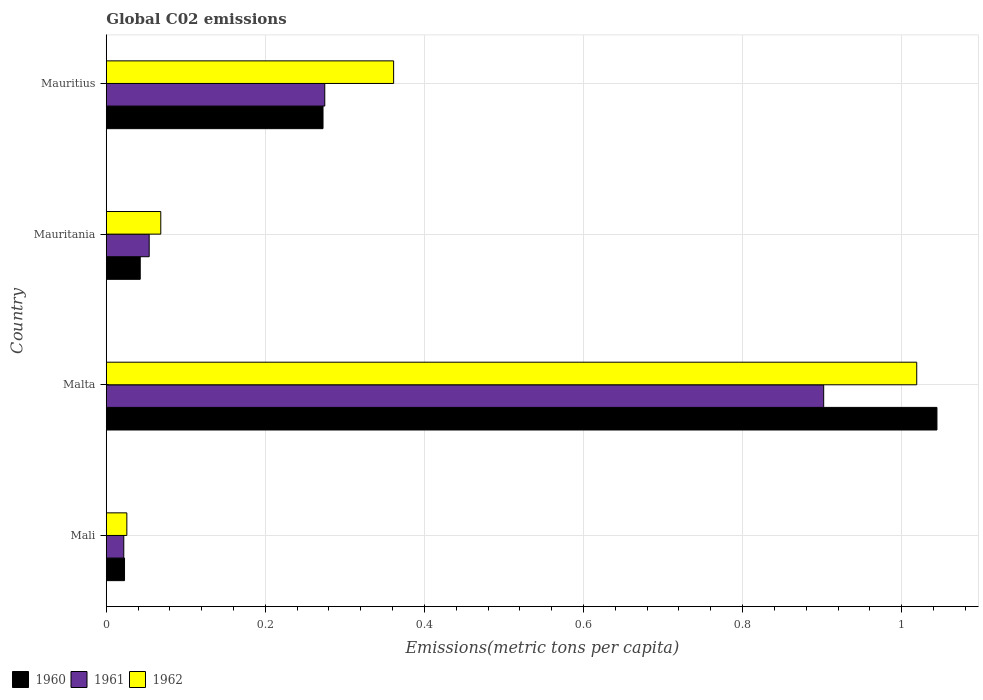How many groups of bars are there?
Offer a very short reply. 4. Are the number of bars per tick equal to the number of legend labels?
Keep it short and to the point. Yes. How many bars are there on the 2nd tick from the bottom?
Provide a succinct answer. 3. What is the label of the 4th group of bars from the top?
Ensure brevity in your answer.  Mali. In how many cases, is the number of bars for a given country not equal to the number of legend labels?
Your answer should be very brief. 0. What is the amount of CO2 emitted in in 1960 in Mauritania?
Provide a short and direct response. 0.04. Across all countries, what is the maximum amount of CO2 emitted in in 1962?
Ensure brevity in your answer.  1.02. Across all countries, what is the minimum amount of CO2 emitted in in 1961?
Give a very brief answer. 0.02. In which country was the amount of CO2 emitted in in 1961 maximum?
Your answer should be very brief. Malta. In which country was the amount of CO2 emitted in in 1962 minimum?
Make the answer very short. Mali. What is the total amount of CO2 emitted in in 1962 in the graph?
Provide a short and direct response. 1.47. What is the difference between the amount of CO2 emitted in in 1962 in Mali and that in Mauritania?
Offer a terse response. -0.04. What is the difference between the amount of CO2 emitted in in 1961 in Mauritius and the amount of CO2 emitted in in 1962 in Mauritania?
Give a very brief answer. 0.21. What is the average amount of CO2 emitted in in 1961 per country?
Your answer should be compact. 0.31. What is the difference between the amount of CO2 emitted in in 1962 and amount of CO2 emitted in in 1960 in Mali?
Offer a very short reply. 0. In how many countries, is the amount of CO2 emitted in in 1962 greater than 0.56 metric tons per capita?
Make the answer very short. 1. What is the ratio of the amount of CO2 emitted in in 1960 in Mauritania to that in Mauritius?
Ensure brevity in your answer.  0.16. Is the difference between the amount of CO2 emitted in in 1962 in Malta and Mauritania greater than the difference between the amount of CO2 emitted in in 1960 in Malta and Mauritania?
Make the answer very short. No. What is the difference between the highest and the second highest amount of CO2 emitted in in 1960?
Keep it short and to the point. 0.77. What is the difference between the highest and the lowest amount of CO2 emitted in in 1960?
Provide a succinct answer. 1.02. In how many countries, is the amount of CO2 emitted in in 1961 greater than the average amount of CO2 emitted in in 1961 taken over all countries?
Your response must be concise. 1. What does the 3rd bar from the bottom in Mali represents?
Your response must be concise. 1962. How many bars are there?
Offer a very short reply. 12. Are all the bars in the graph horizontal?
Provide a short and direct response. Yes. Are the values on the major ticks of X-axis written in scientific E-notation?
Offer a very short reply. No. Does the graph contain grids?
Keep it short and to the point. Yes. How many legend labels are there?
Your answer should be very brief. 3. How are the legend labels stacked?
Make the answer very short. Horizontal. What is the title of the graph?
Ensure brevity in your answer.  Global C02 emissions. What is the label or title of the X-axis?
Provide a short and direct response. Emissions(metric tons per capita). What is the Emissions(metric tons per capita) of 1960 in Mali?
Provide a short and direct response. 0.02. What is the Emissions(metric tons per capita) in 1961 in Mali?
Offer a very short reply. 0.02. What is the Emissions(metric tons per capita) in 1962 in Mali?
Make the answer very short. 0.03. What is the Emissions(metric tons per capita) of 1960 in Malta?
Give a very brief answer. 1.04. What is the Emissions(metric tons per capita) of 1961 in Malta?
Provide a short and direct response. 0.9. What is the Emissions(metric tons per capita) in 1962 in Malta?
Your answer should be very brief. 1.02. What is the Emissions(metric tons per capita) of 1960 in Mauritania?
Offer a terse response. 0.04. What is the Emissions(metric tons per capita) in 1961 in Mauritania?
Provide a succinct answer. 0.05. What is the Emissions(metric tons per capita) in 1962 in Mauritania?
Ensure brevity in your answer.  0.07. What is the Emissions(metric tons per capita) of 1960 in Mauritius?
Your answer should be compact. 0.27. What is the Emissions(metric tons per capita) in 1961 in Mauritius?
Your answer should be compact. 0.27. What is the Emissions(metric tons per capita) in 1962 in Mauritius?
Provide a succinct answer. 0.36. Across all countries, what is the maximum Emissions(metric tons per capita) in 1960?
Offer a terse response. 1.04. Across all countries, what is the maximum Emissions(metric tons per capita) in 1961?
Make the answer very short. 0.9. Across all countries, what is the maximum Emissions(metric tons per capita) in 1962?
Offer a very short reply. 1.02. Across all countries, what is the minimum Emissions(metric tons per capita) in 1960?
Your answer should be compact. 0.02. Across all countries, what is the minimum Emissions(metric tons per capita) in 1961?
Your answer should be compact. 0.02. Across all countries, what is the minimum Emissions(metric tons per capita) in 1962?
Your answer should be very brief. 0.03. What is the total Emissions(metric tons per capita) in 1960 in the graph?
Offer a terse response. 1.38. What is the total Emissions(metric tons per capita) in 1961 in the graph?
Offer a terse response. 1.25. What is the total Emissions(metric tons per capita) in 1962 in the graph?
Your answer should be compact. 1.47. What is the difference between the Emissions(metric tons per capita) of 1960 in Mali and that in Malta?
Keep it short and to the point. -1.02. What is the difference between the Emissions(metric tons per capita) of 1961 in Mali and that in Malta?
Your answer should be compact. -0.88. What is the difference between the Emissions(metric tons per capita) in 1962 in Mali and that in Malta?
Your response must be concise. -0.99. What is the difference between the Emissions(metric tons per capita) of 1960 in Mali and that in Mauritania?
Offer a terse response. -0.02. What is the difference between the Emissions(metric tons per capita) in 1961 in Mali and that in Mauritania?
Give a very brief answer. -0.03. What is the difference between the Emissions(metric tons per capita) of 1962 in Mali and that in Mauritania?
Keep it short and to the point. -0.04. What is the difference between the Emissions(metric tons per capita) of 1960 in Mali and that in Mauritius?
Your response must be concise. -0.25. What is the difference between the Emissions(metric tons per capita) of 1961 in Mali and that in Mauritius?
Your answer should be very brief. -0.25. What is the difference between the Emissions(metric tons per capita) of 1962 in Mali and that in Mauritius?
Your answer should be very brief. -0.34. What is the difference between the Emissions(metric tons per capita) of 1961 in Malta and that in Mauritania?
Your response must be concise. 0.85. What is the difference between the Emissions(metric tons per capita) of 1962 in Malta and that in Mauritania?
Offer a very short reply. 0.95. What is the difference between the Emissions(metric tons per capita) of 1960 in Malta and that in Mauritius?
Offer a terse response. 0.77. What is the difference between the Emissions(metric tons per capita) of 1961 in Malta and that in Mauritius?
Your response must be concise. 0.63. What is the difference between the Emissions(metric tons per capita) in 1962 in Malta and that in Mauritius?
Keep it short and to the point. 0.66. What is the difference between the Emissions(metric tons per capita) of 1960 in Mauritania and that in Mauritius?
Give a very brief answer. -0.23. What is the difference between the Emissions(metric tons per capita) of 1961 in Mauritania and that in Mauritius?
Provide a short and direct response. -0.22. What is the difference between the Emissions(metric tons per capita) in 1962 in Mauritania and that in Mauritius?
Give a very brief answer. -0.29. What is the difference between the Emissions(metric tons per capita) of 1960 in Mali and the Emissions(metric tons per capita) of 1961 in Malta?
Ensure brevity in your answer.  -0.88. What is the difference between the Emissions(metric tons per capita) of 1960 in Mali and the Emissions(metric tons per capita) of 1962 in Malta?
Your response must be concise. -1. What is the difference between the Emissions(metric tons per capita) in 1961 in Mali and the Emissions(metric tons per capita) in 1962 in Malta?
Offer a very short reply. -1. What is the difference between the Emissions(metric tons per capita) of 1960 in Mali and the Emissions(metric tons per capita) of 1961 in Mauritania?
Offer a terse response. -0.03. What is the difference between the Emissions(metric tons per capita) of 1960 in Mali and the Emissions(metric tons per capita) of 1962 in Mauritania?
Your answer should be very brief. -0.05. What is the difference between the Emissions(metric tons per capita) of 1961 in Mali and the Emissions(metric tons per capita) of 1962 in Mauritania?
Your response must be concise. -0.05. What is the difference between the Emissions(metric tons per capita) in 1960 in Mali and the Emissions(metric tons per capita) in 1961 in Mauritius?
Give a very brief answer. -0.25. What is the difference between the Emissions(metric tons per capita) in 1960 in Mali and the Emissions(metric tons per capita) in 1962 in Mauritius?
Give a very brief answer. -0.34. What is the difference between the Emissions(metric tons per capita) of 1961 in Mali and the Emissions(metric tons per capita) of 1962 in Mauritius?
Keep it short and to the point. -0.34. What is the difference between the Emissions(metric tons per capita) in 1960 in Malta and the Emissions(metric tons per capita) in 1961 in Mauritania?
Your response must be concise. 0.99. What is the difference between the Emissions(metric tons per capita) of 1960 in Malta and the Emissions(metric tons per capita) of 1962 in Mauritania?
Offer a terse response. 0.98. What is the difference between the Emissions(metric tons per capita) of 1961 in Malta and the Emissions(metric tons per capita) of 1962 in Mauritania?
Make the answer very short. 0.83. What is the difference between the Emissions(metric tons per capita) in 1960 in Malta and the Emissions(metric tons per capita) in 1961 in Mauritius?
Offer a very short reply. 0.77. What is the difference between the Emissions(metric tons per capita) of 1960 in Malta and the Emissions(metric tons per capita) of 1962 in Mauritius?
Your answer should be compact. 0.68. What is the difference between the Emissions(metric tons per capita) in 1961 in Malta and the Emissions(metric tons per capita) in 1962 in Mauritius?
Ensure brevity in your answer.  0.54. What is the difference between the Emissions(metric tons per capita) in 1960 in Mauritania and the Emissions(metric tons per capita) in 1961 in Mauritius?
Give a very brief answer. -0.23. What is the difference between the Emissions(metric tons per capita) in 1960 in Mauritania and the Emissions(metric tons per capita) in 1962 in Mauritius?
Ensure brevity in your answer.  -0.32. What is the difference between the Emissions(metric tons per capita) in 1961 in Mauritania and the Emissions(metric tons per capita) in 1962 in Mauritius?
Ensure brevity in your answer.  -0.31. What is the average Emissions(metric tons per capita) of 1960 per country?
Provide a succinct answer. 0.35. What is the average Emissions(metric tons per capita) in 1961 per country?
Give a very brief answer. 0.31. What is the average Emissions(metric tons per capita) of 1962 per country?
Ensure brevity in your answer.  0.37. What is the difference between the Emissions(metric tons per capita) in 1960 and Emissions(metric tons per capita) in 1961 in Mali?
Make the answer very short. 0. What is the difference between the Emissions(metric tons per capita) in 1960 and Emissions(metric tons per capita) in 1962 in Mali?
Make the answer very short. -0. What is the difference between the Emissions(metric tons per capita) of 1961 and Emissions(metric tons per capita) of 1962 in Mali?
Give a very brief answer. -0. What is the difference between the Emissions(metric tons per capita) of 1960 and Emissions(metric tons per capita) of 1961 in Malta?
Provide a short and direct response. 0.14. What is the difference between the Emissions(metric tons per capita) of 1960 and Emissions(metric tons per capita) of 1962 in Malta?
Offer a terse response. 0.03. What is the difference between the Emissions(metric tons per capita) of 1961 and Emissions(metric tons per capita) of 1962 in Malta?
Keep it short and to the point. -0.12. What is the difference between the Emissions(metric tons per capita) of 1960 and Emissions(metric tons per capita) of 1961 in Mauritania?
Give a very brief answer. -0.01. What is the difference between the Emissions(metric tons per capita) in 1960 and Emissions(metric tons per capita) in 1962 in Mauritania?
Make the answer very short. -0.03. What is the difference between the Emissions(metric tons per capita) of 1961 and Emissions(metric tons per capita) of 1962 in Mauritania?
Give a very brief answer. -0.01. What is the difference between the Emissions(metric tons per capita) in 1960 and Emissions(metric tons per capita) in 1961 in Mauritius?
Ensure brevity in your answer.  -0. What is the difference between the Emissions(metric tons per capita) of 1960 and Emissions(metric tons per capita) of 1962 in Mauritius?
Give a very brief answer. -0.09. What is the difference between the Emissions(metric tons per capita) of 1961 and Emissions(metric tons per capita) of 1962 in Mauritius?
Keep it short and to the point. -0.09. What is the ratio of the Emissions(metric tons per capita) in 1960 in Mali to that in Malta?
Your answer should be very brief. 0.02. What is the ratio of the Emissions(metric tons per capita) of 1961 in Mali to that in Malta?
Offer a terse response. 0.02. What is the ratio of the Emissions(metric tons per capita) of 1962 in Mali to that in Malta?
Provide a short and direct response. 0.03. What is the ratio of the Emissions(metric tons per capita) in 1960 in Mali to that in Mauritania?
Provide a short and direct response. 0.54. What is the ratio of the Emissions(metric tons per capita) in 1961 in Mali to that in Mauritania?
Your answer should be very brief. 0.41. What is the ratio of the Emissions(metric tons per capita) of 1962 in Mali to that in Mauritania?
Give a very brief answer. 0.38. What is the ratio of the Emissions(metric tons per capita) of 1960 in Mali to that in Mauritius?
Your answer should be compact. 0.08. What is the ratio of the Emissions(metric tons per capita) in 1961 in Mali to that in Mauritius?
Provide a short and direct response. 0.08. What is the ratio of the Emissions(metric tons per capita) of 1962 in Mali to that in Mauritius?
Ensure brevity in your answer.  0.07. What is the ratio of the Emissions(metric tons per capita) of 1960 in Malta to that in Mauritania?
Keep it short and to the point. 24.44. What is the ratio of the Emissions(metric tons per capita) of 1961 in Malta to that in Mauritania?
Your answer should be compact. 16.71. What is the ratio of the Emissions(metric tons per capita) of 1962 in Malta to that in Mauritania?
Provide a succinct answer. 14.86. What is the ratio of the Emissions(metric tons per capita) of 1960 in Malta to that in Mauritius?
Your answer should be compact. 3.83. What is the ratio of the Emissions(metric tons per capita) in 1961 in Malta to that in Mauritius?
Offer a very short reply. 3.28. What is the ratio of the Emissions(metric tons per capita) in 1962 in Malta to that in Mauritius?
Give a very brief answer. 2.82. What is the ratio of the Emissions(metric tons per capita) in 1960 in Mauritania to that in Mauritius?
Keep it short and to the point. 0.16. What is the ratio of the Emissions(metric tons per capita) in 1961 in Mauritania to that in Mauritius?
Your answer should be very brief. 0.2. What is the ratio of the Emissions(metric tons per capita) of 1962 in Mauritania to that in Mauritius?
Your response must be concise. 0.19. What is the difference between the highest and the second highest Emissions(metric tons per capita) in 1960?
Provide a succinct answer. 0.77. What is the difference between the highest and the second highest Emissions(metric tons per capita) in 1961?
Your response must be concise. 0.63. What is the difference between the highest and the second highest Emissions(metric tons per capita) in 1962?
Your response must be concise. 0.66. What is the difference between the highest and the lowest Emissions(metric tons per capita) of 1960?
Your answer should be compact. 1.02. What is the difference between the highest and the lowest Emissions(metric tons per capita) of 1961?
Ensure brevity in your answer.  0.88. 